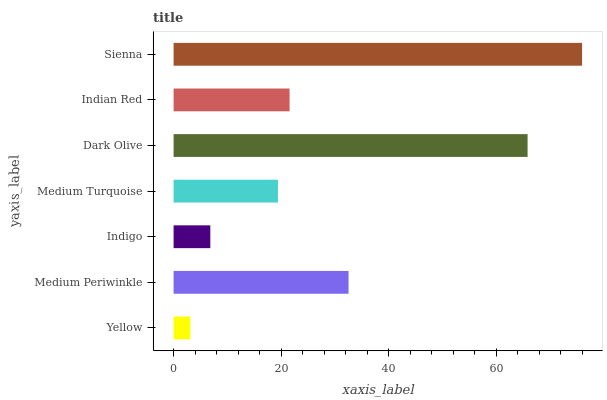Is Yellow the minimum?
Answer yes or no. Yes. Is Sienna the maximum?
Answer yes or no. Yes. Is Medium Periwinkle the minimum?
Answer yes or no. No. Is Medium Periwinkle the maximum?
Answer yes or no. No. Is Medium Periwinkle greater than Yellow?
Answer yes or no. Yes. Is Yellow less than Medium Periwinkle?
Answer yes or no. Yes. Is Yellow greater than Medium Periwinkle?
Answer yes or no. No. Is Medium Periwinkle less than Yellow?
Answer yes or no. No. Is Indian Red the high median?
Answer yes or no. Yes. Is Indian Red the low median?
Answer yes or no. Yes. Is Sienna the high median?
Answer yes or no. No. Is Medium Periwinkle the low median?
Answer yes or no. No. 